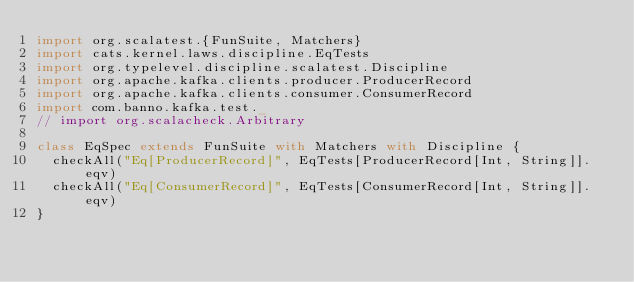<code> <loc_0><loc_0><loc_500><loc_500><_Scala_>import org.scalatest.{FunSuite, Matchers}
import cats.kernel.laws.discipline.EqTests
import org.typelevel.discipline.scalatest.Discipline
import org.apache.kafka.clients.producer.ProducerRecord
import org.apache.kafka.clients.consumer.ConsumerRecord
import com.banno.kafka.test._
// import org.scalacheck.Arbitrary

class EqSpec extends FunSuite with Matchers with Discipline {
  checkAll("Eq[ProducerRecord]", EqTests[ProducerRecord[Int, String]].eqv)
  checkAll("Eq[ConsumerRecord]", EqTests[ConsumerRecord[Int, String]].eqv)
}
</code> 